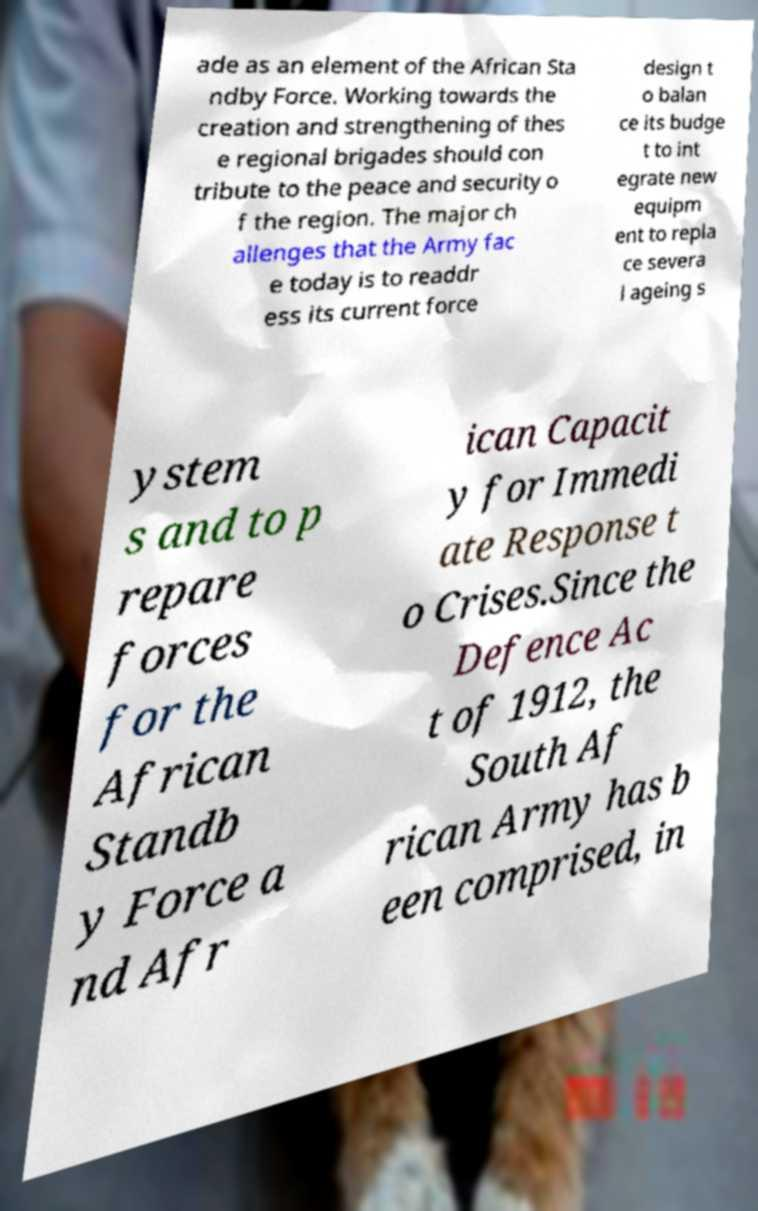Could you assist in decoding the text presented in this image and type it out clearly? ade as an element of the African Sta ndby Force. Working towards the creation and strengthening of thes e regional brigades should con tribute to the peace and security o f the region. The major ch allenges that the Army fac e today is to readdr ess its current force design t o balan ce its budge t to int egrate new equipm ent to repla ce severa l ageing s ystem s and to p repare forces for the African Standb y Force a nd Afr ican Capacit y for Immedi ate Response t o Crises.Since the Defence Ac t of 1912, the South Af rican Army has b een comprised, in 